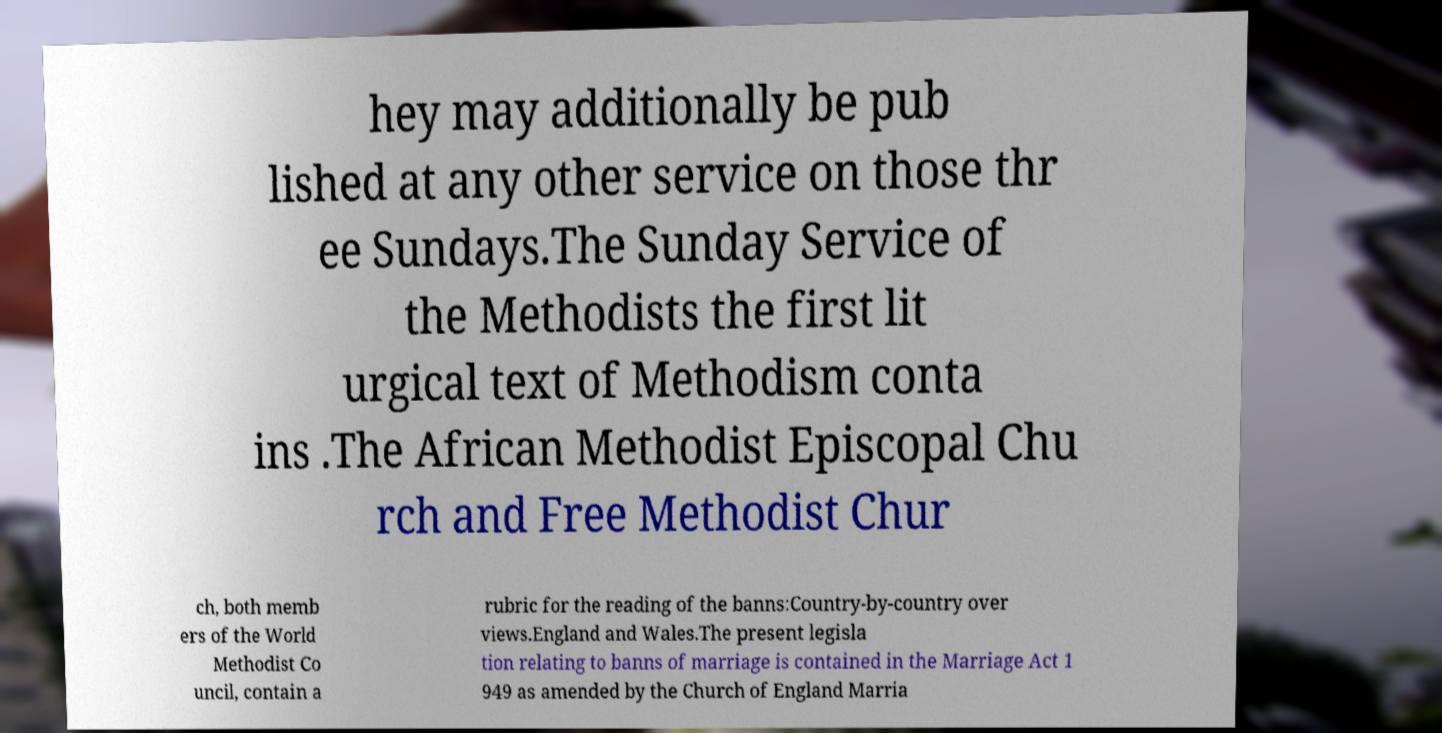Please identify and transcribe the text found in this image. hey may additionally be pub lished at any other service on those thr ee Sundays.The Sunday Service of the Methodists the first lit urgical text of Methodism conta ins .The African Methodist Episcopal Chu rch and Free Methodist Chur ch, both memb ers of the World Methodist Co uncil, contain a rubric for the reading of the banns:Country-by-country over views.England and Wales.The present legisla tion relating to banns of marriage is contained in the Marriage Act 1 949 as amended by the Church of England Marria 